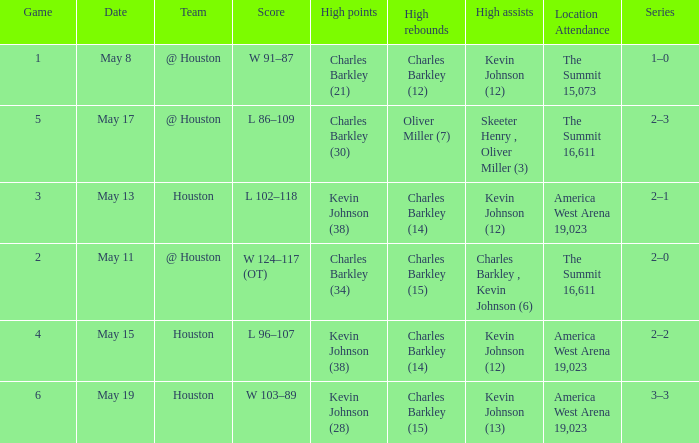In what series did Charles Barkley (34) did most high points? 2–0. 